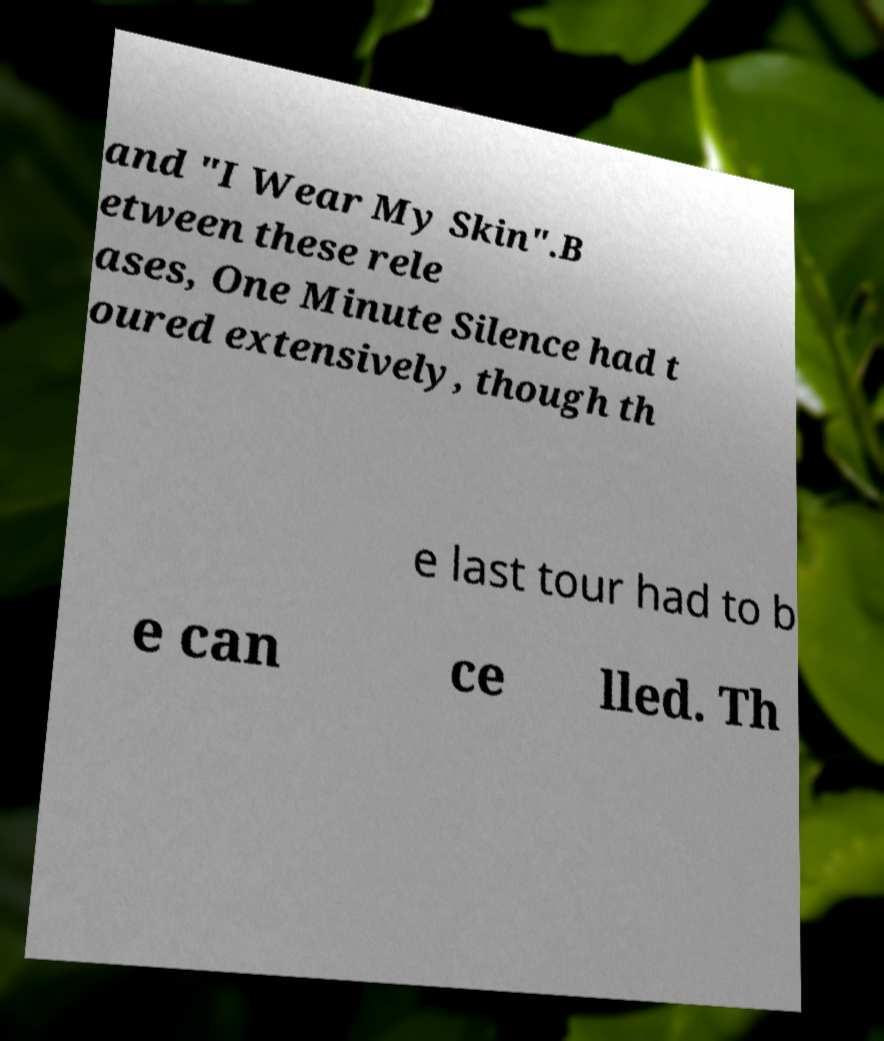There's text embedded in this image that I need extracted. Can you transcribe it verbatim? and "I Wear My Skin".B etween these rele ases, One Minute Silence had t oured extensively, though th e last tour had to b e can ce lled. Th 